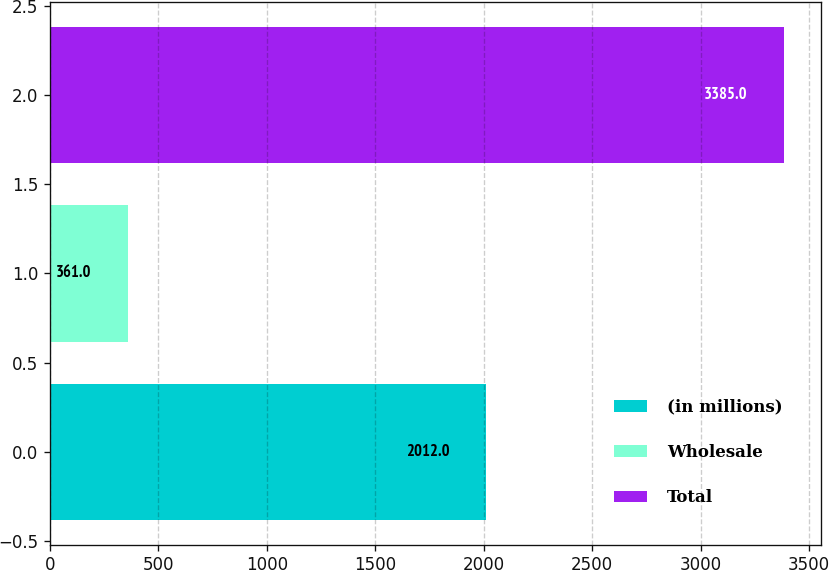Convert chart to OTSL. <chart><loc_0><loc_0><loc_500><loc_500><bar_chart><fcel>(in millions)<fcel>Wholesale<fcel>Total<nl><fcel>2012<fcel>361<fcel>3385<nl></chart> 